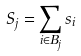Convert formula to latex. <formula><loc_0><loc_0><loc_500><loc_500>S _ { j } = \sum _ { i \in B _ { j } } s _ { i }</formula> 